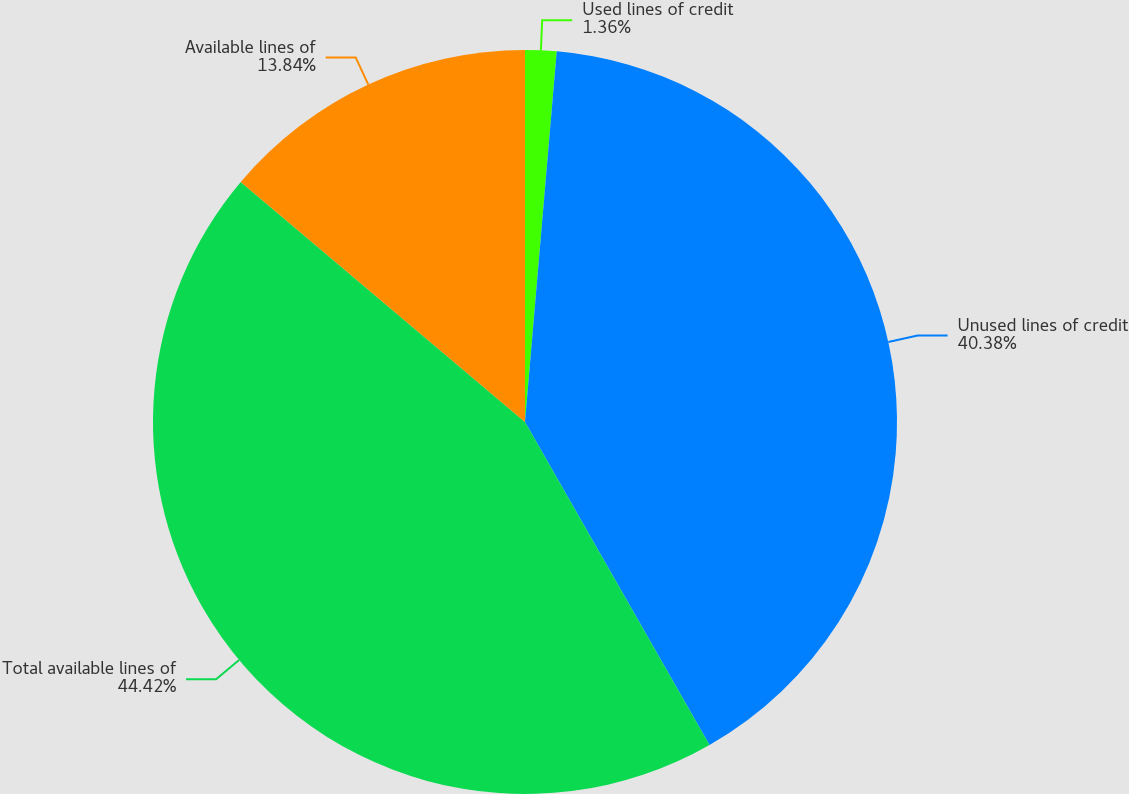<chart> <loc_0><loc_0><loc_500><loc_500><pie_chart><fcel>Used lines of credit<fcel>Unused lines of credit<fcel>Total available lines of<fcel>Available lines of<nl><fcel>1.36%<fcel>40.38%<fcel>44.42%<fcel>13.84%<nl></chart> 